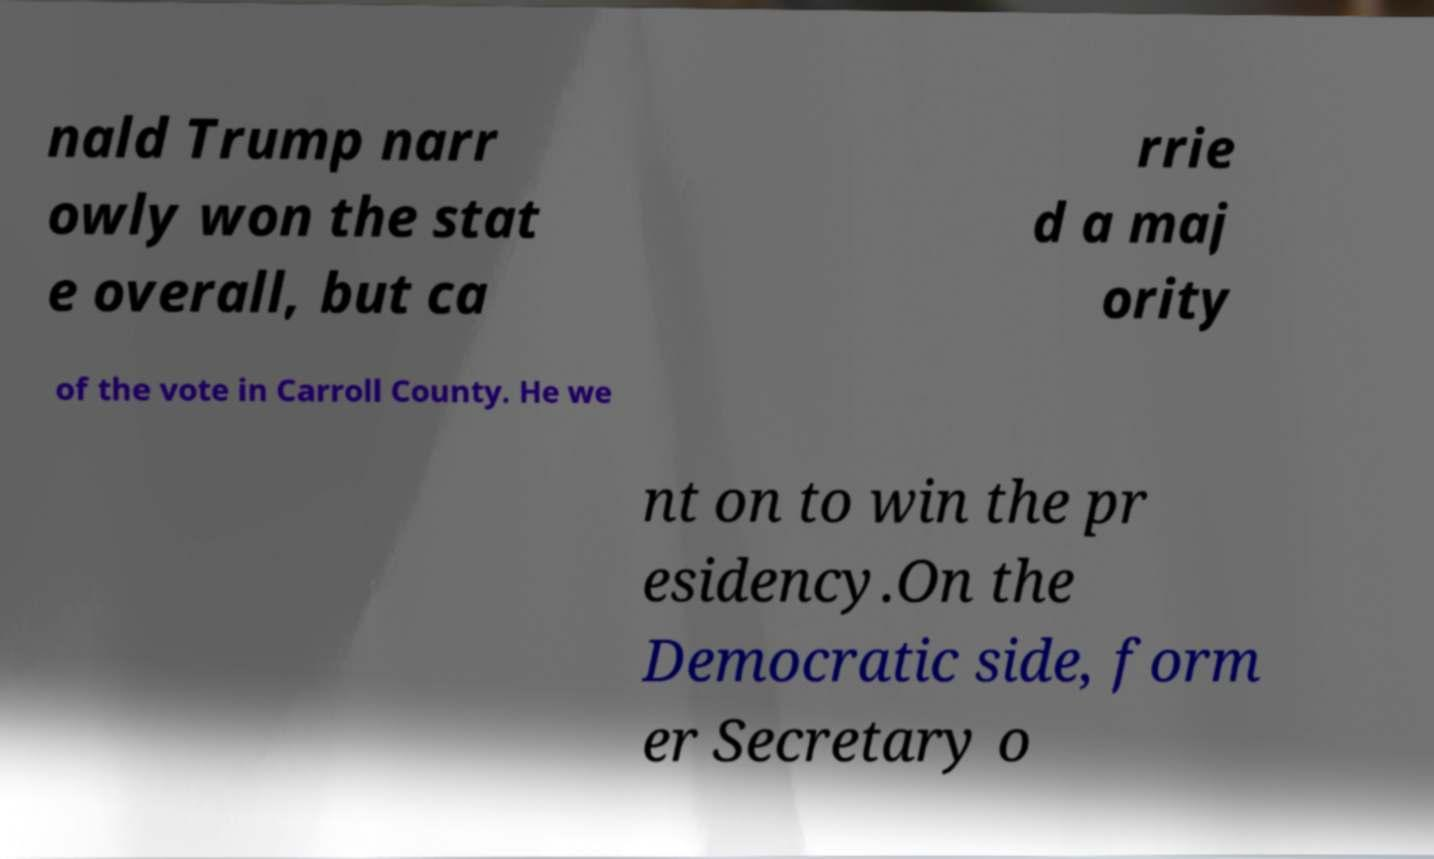For documentation purposes, I need the text within this image transcribed. Could you provide that? nald Trump narr owly won the stat e overall, but ca rrie d a maj ority of the vote in Carroll County. He we nt on to win the pr esidency.On the Democratic side, form er Secretary o 